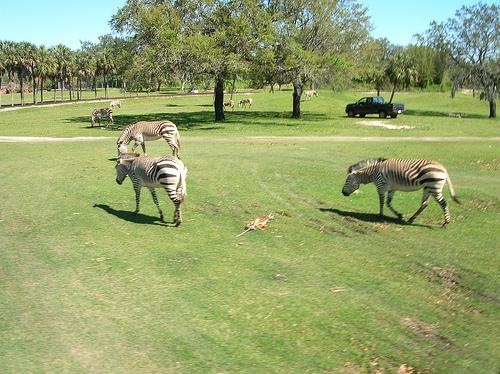Describe the scene in the image using simple words and short phrases. Blue truck, green grass, zebras grazing, trees, shadows, tire tracks, long tails and manes. Mention at least two animals present in the picture and describe the surroundings. Zebras are walking and grazing in a field with green grass, trees, and a blue truck parked nearby. What is the most unusual element in the image and what is the natural setting? The blue truck parked in a field with zebras grazing around and trees in the background. Imagine you're describing the image to a child. In simple words, explain what the picture shows. A picture of a blue truck on green grass with lots of friendly zebras walking around and big trees in the back. If the image were a painting, what would be the main focal point and the background elements? The main focal point would be the blue truck and the zebras, with the green grass, trees, shadows, and tire tracks as background elements. Provide a brief description of the main focus of the image. A blue truck parked on green grass with zebras grazing around and trees in the background. Describe three different aspects of the image: the vehicle, the animals, and the vegetation. A blue truck parked on grass, black and white zebras grazing in the field, and a variety of trees surrounding the scene. List three prominent colors in the image and the subjects they are associated with. Blue - truck, green - grass and trees, black and white - zebras. What is the primary focus of the image and what are some secondary elements? Primary focus: blue truck and zebras, secondary elements: green grass, trees, shadows, and tire tracks. Narrate the key elements and actions you observe in the image. There are zebras grazing on a green field, a blue truck parked near them, and several trees surrounding the scene. 